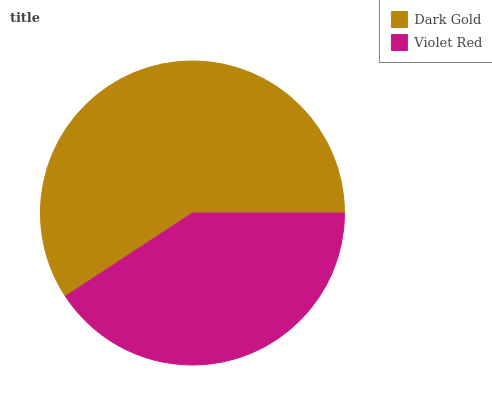Is Violet Red the minimum?
Answer yes or no. Yes. Is Dark Gold the maximum?
Answer yes or no. Yes. Is Violet Red the maximum?
Answer yes or no. No. Is Dark Gold greater than Violet Red?
Answer yes or no. Yes. Is Violet Red less than Dark Gold?
Answer yes or no. Yes. Is Violet Red greater than Dark Gold?
Answer yes or no. No. Is Dark Gold less than Violet Red?
Answer yes or no. No. Is Dark Gold the high median?
Answer yes or no. Yes. Is Violet Red the low median?
Answer yes or no. Yes. Is Violet Red the high median?
Answer yes or no. No. Is Dark Gold the low median?
Answer yes or no. No. 